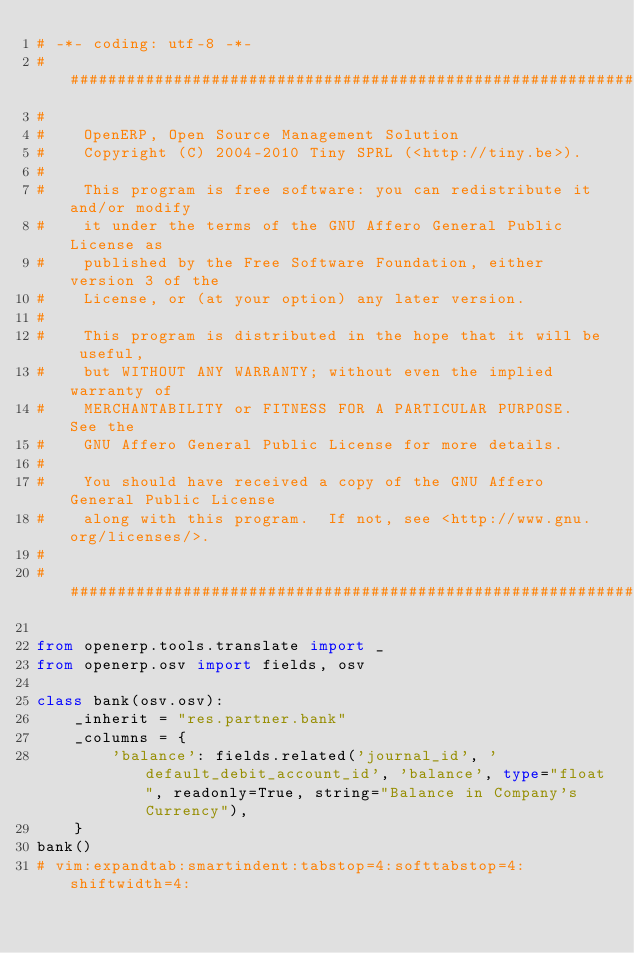<code> <loc_0><loc_0><loc_500><loc_500><_Python_># -*- coding: utf-8 -*-
##############################################################################
#
#    OpenERP, Open Source Management Solution
#    Copyright (C) 2004-2010 Tiny SPRL (<http://tiny.be>).
#
#    This program is free software: you can redistribute it and/or modify
#    it under the terms of the GNU Affero General Public License as
#    published by the Free Software Foundation, either version 3 of the
#    License, or (at your option) any later version.
#
#    This program is distributed in the hope that it will be useful,
#    but WITHOUT ANY WARRANTY; without even the implied warranty of
#    MERCHANTABILITY or FITNESS FOR A PARTICULAR PURPOSE.  See the
#    GNU Affero General Public License for more details.
#
#    You should have received a copy of the GNU Affero General Public License
#    along with this program.  If not, see <http://www.gnu.org/licenses/>.
#
##############################################################################

from openerp.tools.translate import _
from openerp.osv import fields, osv

class bank(osv.osv):
    _inherit = "res.partner.bank"
    _columns = {
        'balance': fields.related('journal_id', 'default_debit_account_id', 'balance', type="float", readonly=True, string="Balance in Company's Currency"),
    }
bank()
# vim:expandtab:smartindent:tabstop=4:softtabstop=4:shiftwidth=4:
</code> 